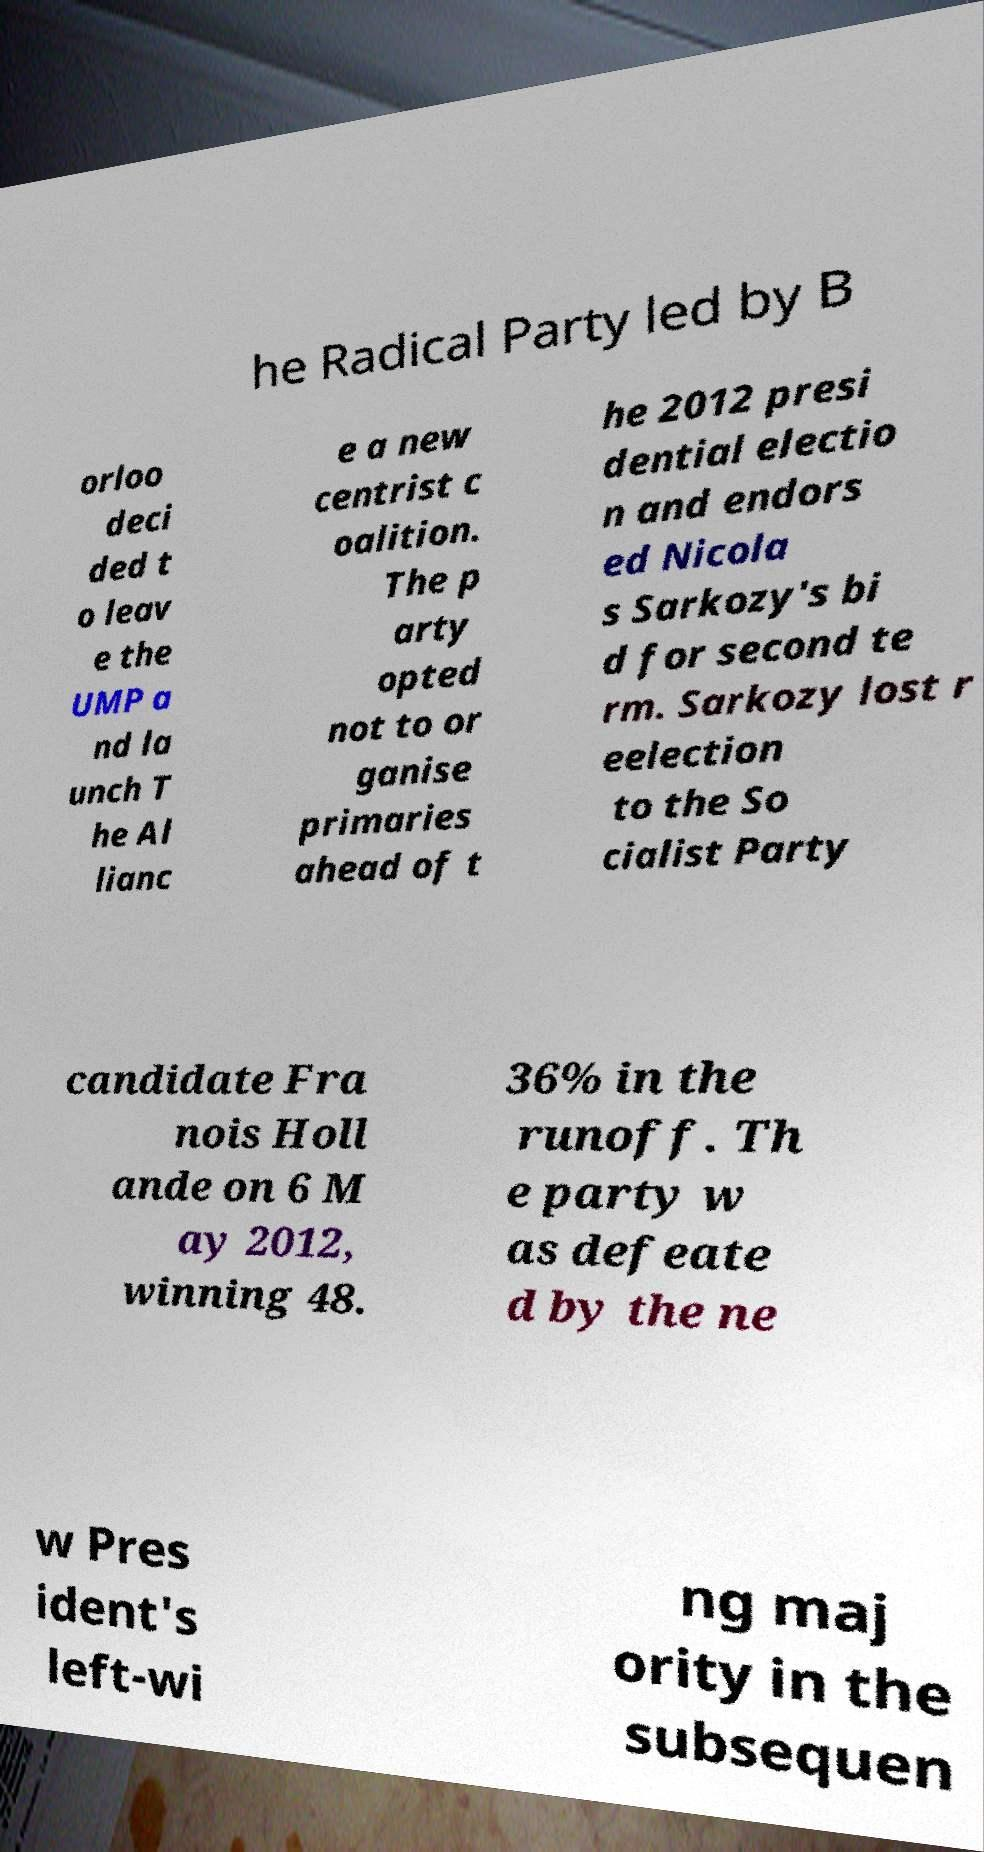Please identify and transcribe the text found in this image. he Radical Party led by B orloo deci ded t o leav e the UMP a nd la unch T he Al lianc e a new centrist c oalition. The p arty opted not to or ganise primaries ahead of t he 2012 presi dential electio n and endors ed Nicola s Sarkozy's bi d for second te rm. Sarkozy lost r eelection to the So cialist Party candidate Fra nois Holl ande on 6 M ay 2012, winning 48. 36% in the runoff. Th e party w as defeate d by the ne w Pres ident's left-wi ng maj ority in the subsequen 